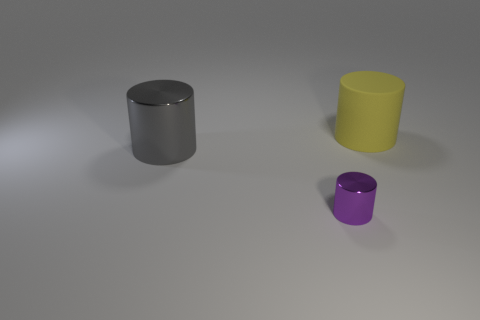Add 1 large gray things. How many objects exist? 4 Subtract all cylinders. Subtract all purple metal blocks. How many objects are left? 0 Add 1 tiny purple cylinders. How many tiny purple cylinders are left? 2 Add 3 small cylinders. How many small cylinders exist? 4 Subtract 0 yellow balls. How many objects are left? 3 